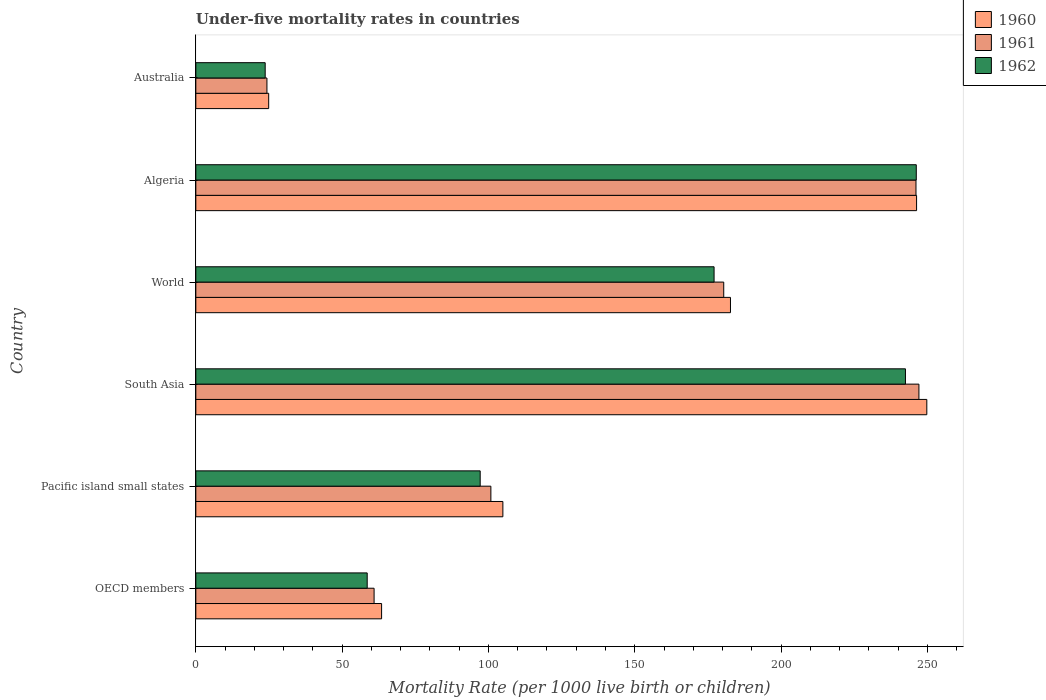Are the number of bars per tick equal to the number of legend labels?
Make the answer very short. Yes. Are the number of bars on each tick of the Y-axis equal?
Your answer should be very brief. Yes. How many bars are there on the 5th tick from the top?
Provide a succinct answer. 3. What is the under-five mortality rate in 1962 in Pacific island small states?
Provide a short and direct response. 97.17. Across all countries, what is the maximum under-five mortality rate in 1960?
Your answer should be very brief. 249.8. Across all countries, what is the minimum under-five mortality rate in 1960?
Your answer should be compact. 24.9. In which country was the under-five mortality rate in 1962 maximum?
Offer a very short reply. Algeria. In which country was the under-five mortality rate in 1962 minimum?
Provide a short and direct response. Australia. What is the total under-five mortality rate in 1961 in the graph?
Offer a terse response. 859.64. What is the difference between the under-five mortality rate in 1960 in Algeria and that in Australia?
Your response must be concise. 221.4. What is the difference between the under-five mortality rate in 1960 in Algeria and the under-five mortality rate in 1961 in Pacific island small states?
Offer a very short reply. 145.47. What is the average under-five mortality rate in 1960 per country?
Give a very brief answer. 145.35. What is the difference between the under-five mortality rate in 1961 and under-five mortality rate in 1960 in OECD members?
Keep it short and to the point. -2.57. What is the ratio of the under-five mortality rate in 1961 in OECD members to that in World?
Offer a very short reply. 0.34. Is the under-five mortality rate in 1960 in OECD members less than that in Pacific island small states?
Offer a very short reply. Yes. Is the difference between the under-five mortality rate in 1961 in Australia and Pacific island small states greater than the difference between the under-five mortality rate in 1960 in Australia and Pacific island small states?
Give a very brief answer. Yes. What is the difference between the highest and the second highest under-five mortality rate in 1962?
Offer a very short reply. 3.7. What is the difference between the highest and the lowest under-five mortality rate in 1960?
Offer a very short reply. 224.9. What does the 1st bar from the top in Algeria represents?
Your answer should be compact. 1962. What does the 2nd bar from the bottom in Australia represents?
Give a very brief answer. 1961. How many bars are there?
Offer a terse response. 18. How many countries are there in the graph?
Keep it short and to the point. 6. What is the difference between two consecutive major ticks on the X-axis?
Your answer should be compact. 50. Does the graph contain any zero values?
Offer a terse response. No. How are the legend labels stacked?
Provide a succinct answer. Vertical. What is the title of the graph?
Keep it short and to the point. Under-five mortality rates in countries. Does "2012" appear as one of the legend labels in the graph?
Offer a very short reply. No. What is the label or title of the X-axis?
Your answer should be compact. Mortality Rate (per 1000 live birth or children). What is the Mortality Rate (per 1000 live birth or children) in 1960 in OECD members?
Provide a short and direct response. 63.48. What is the Mortality Rate (per 1000 live birth or children) in 1961 in OECD members?
Your response must be concise. 60.92. What is the Mortality Rate (per 1000 live birth or children) of 1962 in OECD members?
Keep it short and to the point. 58.57. What is the Mortality Rate (per 1000 live birth or children) in 1960 in Pacific island small states?
Offer a terse response. 104.93. What is the Mortality Rate (per 1000 live birth or children) in 1961 in Pacific island small states?
Your answer should be very brief. 100.83. What is the Mortality Rate (per 1000 live birth or children) in 1962 in Pacific island small states?
Provide a succinct answer. 97.17. What is the Mortality Rate (per 1000 live birth or children) of 1960 in South Asia?
Give a very brief answer. 249.8. What is the Mortality Rate (per 1000 live birth or children) in 1961 in South Asia?
Offer a terse response. 247.1. What is the Mortality Rate (per 1000 live birth or children) of 1962 in South Asia?
Ensure brevity in your answer.  242.5. What is the Mortality Rate (per 1000 live birth or children) of 1960 in World?
Provide a succinct answer. 182.7. What is the Mortality Rate (per 1000 live birth or children) in 1961 in World?
Keep it short and to the point. 180.4. What is the Mortality Rate (per 1000 live birth or children) of 1962 in World?
Make the answer very short. 177.1. What is the Mortality Rate (per 1000 live birth or children) of 1960 in Algeria?
Provide a succinct answer. 246.3. What is the Mortality Rate (per 1000 live birth or children) in 1961 in Algeria?
Your response must be concise. 246.1. What is the Mortality Rate (per 1000 live birth or children) in 1962 in Algeria?
Your answer should be compact. 246.2. What is the Mortality Rate (per 1000 live birth or children) in 1960 in Australia?
Your answer should be very brief. 24.9. What is the Mortality Rate (per 1000 live birth or children) of 1961 in Australia?
Your answer should be very brief. 24.3. What is the Mortality Rate (per 1000 live birth or children) of 1962 in Australia?
Give a very brief answer. 23.7. Across all countries, what is the maximum Mortality Rate (per 1000 live birth or children) in 1960?
Provide a short and direct response. 249.8. Across all countries, what is the maximum Mortality Rate (per 1000 live birth or children) in 1961?
Make the answer very short. 247.1. Across all countries, what is the maximum Mortality Rate (per 1000 live birth or children) of 1962?
Your answer should be compact. 246.2. Across all countries, what is the minimum Mortality Rate (per 1000 live birth or children) in 1960?
Make the answer very short. 24.9. Across all countries, what is the minimum Mortality Rate (per 1000 live birth or children) in 1961?
Keep it short and to the point. 24.3. Across all countries, what is the minimum Mortality Rate (per 1000 live birth or children) of 1962?
Your response must be concise. 23.7. What is the total Mortality Rate (per 1000 live birth or children) in 1960 in the graph?
Your answer should be very brief. 872.11. What is the total Mortality Rate (per 1000 live birth or children) of 1961 in the graph?
Ensure brevity in your answer.  859.64. What is the total Mortality Rate (per 1000 live birth or children) of 1962 in the graph?
Offer a terse response. 845.24. What is the difference between the Mortality Rate (per 1000 live birth or children) of 1960 in OECD members and that in Pacific island small states?
Ensure brevity in your answer.  -41.45. What is the difference between the Mortality Rate (per 1000 live birth or children) in 1961 in OECD members and that in Pacific island small states?
Make the answer very short. -39.91. What is the difference between the Mortality Rate (per 1000 live birth or children) in 1962 in OECD members and that in Pacific island small states?
Keep it short and to the point. -38.61. What is the difference between the Mortality Rate (per 1000 live birth or children) of 1960 in OECD members and that in South Asia?
Offer a terse response. -186.32. What is the difference between the Mortality Rate (per 1000 live birth or children) of 1961 in OECD members and that in South Asia?
Provide a short and direct response. -186.18. What is the difference between the Mortality Rate (per 1000 live birth or children) of 1962 in OECD members and that in South Asia?
Offer a very short reply. -183.93. What is the difference between the Mortality Rate (per 1000 live birth or children) of 1960 in OECD members and that in World?
Give a very brief answer. -119.22. What is the difference between the Mortality Rate (per 1000 live birth or children) of 1961 in OECD members and that in World?
Make the answer very short. -119.48. What is the difference between the Mortality Rate (per 1000 live birth or children) in 1962 in OECD members and that in World?
Your answer should be very brief. -118.53. What is the difference between the Mortality Rate (per 1000 live birth or children) of 1960 in OECD members and that in Algeria?
Offer a terse response. -182.82. What is the difference between the Mortality Rate (per 1000 live birth or children) of 1961 in OECD members and that in Algeria?
Ensure brevity in your answer.  -185.18. What is the difference between the Mortality Rate (per 1000 live birth or children) in 1962 in OECD members and that in Algeria?
Give a very brief answer. -187.63. What is the difference between the Mortality Rate (per 1000 live birth or children) of 1960 in OECD members and that in Australia?
Your answer should be very brief. 38.58. What is the difference between the Mortality Rate (per 1000 live birth or children) of 1961 in OECD members and that in Australia?
Offer a terse response. 36.62. What is the difference between the Mortality Rate (per 1000 live birth or children) of 1962 in OECD members and that in Australia?
Offer a very short reply. 34.87. What is the difference between the Mortality Rate (per 1000 live birth or children) of 1960 in Pacific island small states and that in South Asia?
Your answer should be very brief. -144.87. What is the difference between the Mortality Rate (per 1000 live birth or children) in 1961 in Pacific island small states and that in South Asia?
Provide a succinct answer. -146.27. What is the difference between the Mortality Rate (per 1000 live birth or children) in 1962 in Pacific island small states and that in South Asia?
Keep it short and to the point. -145.33. What is the difference between the Mortality Rate (per 1000 live birth or children) of 1960 in Pacific island small states and that in World?
Your response must be concise. -77.77. What is the difference between the Mortality Rate (per 1000 live birth or children) of 1961 in Pacific island small states and that in World?
Your response must be concise. -79.57. What is the difference between the Mortality Rate (per 1000 live birth or children) in 1962 in Pacific island small states and that in World?
Your response must be concise. -79.93. What is the difference between the Mortality Rate (per 1000 live birth or children) in 1960 in Pacific island small states and that in Algeria?
Offer a very short reply. -141.37. What is the difference between the Mortality Rate (per 1000 live birth or children) in 1961 in Pacific island small states and that in Algeria?
Make the answer very short. -145.27. What is the difference between the Mortality Rate (per 1000 live birth or children) in 1962 in Pacific island small states and that in Algeria?
Keep it short and to the point. -149.03. What is the difference between the Mortality Rate (per 1000 live birth or children) in 1960 in Pacific island small states and that in Australia?
Ensure brevity in your answer.  80.03. What is the difference between the Mortality Rate (per 1000 live birth or children) in 1961 in Pacific island small states and that in Australia?
Offer a very short reply. 76.53. What is the difference between the Mortality Rate (per 1000 live birth or children) of 1962 in Pacific island small states and that in Australia?
Keep it short and to the point. 73.47. What is the difference between the Mortality Rate (per 1000 live birth or children) in 1960 in South Asia and that in World?
Your response must be concise. 67.1. What is the difference between the Mortality Rate (per 1000 live birth or children) in 1961 in South Asia and that in World?
Keep it short and to the point. 66.7. What is the difference between the Mortality Rate (per 1000 live birth or children) of 1962 in South Asia and that in World?
Offer a terse response. 65.4. What is the difference between the Mortality Rate (per 1000 live birth or children) in 1960 in South Asia and that in Algeria?
Provide a succinct answer. 3.5. What is the difference between the Mortality Rate (per 1000 live birth or children) of 1961 in South Asia and that in Algeria?
Your response must be concise. 1. What is the difference between the Mortality Rate (per 1000 live birth or children) of 1962 in South Asia and that in Algeria?
Provide a short and direct response. -3.7. What is the difference between the Mortality Rate (per 1000 live birth or children) of 1960 in South Asia and that in Australia?
Provide a short and direct response. 224.9. What is the difference between the Mortality Rate (per 1000 live birth or children) of 1961 in South Asia and that in Australia?
Your answer should be very brief. 222.8. What is the difference between the Mortality Rate (per 1000 live birth or children) in 1962 in South Asia and that in Australia?
Give a very brief answer. 218.8. What is the difference between the Mortality Rate (per 1000 live birth or children) of 1960 in World and that in Algeria?
Keep it short and to the point. -63.6. What is the difference between the Mortality Rate (per 1000 live birth or children) in 1961 in World and that in Algeria?
Provide a short and direct response. -65.7. What is the difference between the Mortality Rate (per 1000 live birth or children) in 1962 in World and that in Algeria?
Your answer should be compact. -69.1. What is the difference between the Mortality Rate (per 1000 live birth or children) of 1960 in World and that in Australia?
Your answer should be compact. 157.8. What is the difference between the Mortality Rate (per 1000 live birth or children) of 1961 in World and that in Australia?
Offer a terse response. 156.1. What is the difference between the Mortality Rate (per 1000 live birth or children) in 1962 in World and that in Australia?
Keep it short and to the point. 153.4. What is the difference between the Mortality Rate (per 1000 live birth or children) in 1960 in Algeria and that in Australia?
Give a very brief answer. 221.4. What is the difference between the Mortality Rate (per 1000 live birth or children) in 1961 in Algeria and that in Australia?
Make the answer very short. 221.8. What is the difference between the Mortality Rate (per 1000 live birth or children) of 1962 in Algeria and that in Australia?
Offer a terse response. 222.5. What is the difference between the Mortality Rate (per 1000 live birth or children) in 1960 in OECD members and the Mortality Rate (per 1000 live birth or children) in 1961 in Pacific island small states?
Give a very brief answer. -37.35. What is the difference between the Mortality Rate (per 1000 live birth or children) of 1960 in OECD members and the Mortality Rate (per 1000 live birth or children) of 1962 in Pacific island small states?
Make the answer very short. -33.69. What is the difference between the Mortality Rate (per 1000 live birth or children) in 1961 in OECD members and the Mortality Rate (per 1000 live birth or children) in 1962 in Pacific island small states?
Offer a very short reply. -36.26. What is the difference between the Mortality Rate (per 1000 live birth or children) of 1960 in OECD members and the Mortality Rate (per 1000 live birth or children) of 1961 in South Asia?
Your answer should be compact. -183.62. What is the difference between the Mortality Rate (per 1000 live birth or children) of 1960 in OECD members and the Mortality Rate (per 1000 live birth or children) of 1962 in South Asia?
Offer a terse response. -179.02. What is the difference between the Mortality Rate (per 1000 live birth or children) of 1961 in OECD members and the Mortality Rate (per 1000 live birth or children) of 1962 in South Asia?
Give a very brief answer. -181.58. What is the difference between the Mortality Rate (per 1000 live birth or children) of 1960 in OECD members and the Mortality Rate (per 1000 live birth or children) of 1961 in World?
Ensure brevity in your answer.  -116.92. What is the difference between the Mortality Rate (per 1000 live birth or children) in 1960 in OECD members and the Mortality Rate (per 1000 live birth or children) in 1962 in World?
Make the answer very short. -113.62. What is the difference between the Mortality Rate (per 1000 live birth or children) of 1961 in OECD members and the Mortality Rate (per 1000 live birth or children) of 1962 in World?
Make the answer very short. -116.18. What is the difference between the Mortality Rate (per 1000 live birth or children) of 1960 in OECD members and the Mortality Rate (per 1000 live birth or children) of 1961 in Algeria?
Offer a very short reply. -182.62. What is the difference between the Mortality Rate (per 1000 live birth or children) of 1960 in OECD members and the Mortality Rate (per 1000 live birth or children) of 1962 in Algeria?
Your answer should be compact. -182.72. What is the difference between the Mortality Rate (per 1000 live birth or children) of 1961 in OECD members and the Mortality Rate (per 1000 live birth or children) of 1962 in Algeria?
Ensure brevity in your answer.  -185.28. What is the difference between the Mortality Rate (per 1000 live birth or children) of 1960 in OECD members and the Mortality Rate (per 1000 live birth or children) of 1961 in Australia?
Provide a short and direct response. 39.18. What is the difference between the Mortality Rate (per 1000 live birth or children) in 1960 in OECD members and the Mortality Rate (per 1000 live birth or children) in 1962 in Australia?
Offer a terse response. 39.78. What is the difference between the Mortality Rate (per 1000 live birth or children) of 1961 in OECD members and the Mortality Rate (per 1000 live birth or children) of 1962 in Australia?
Offer a terse response. 37.22. What is the difference between the Mortality Rate (per 1000 live birth or children) of 1960 in Pacific island small states and the Mortality Rate (per 1000 live birth or children) of 1961 in South Asia?
Offer a very short reply. -142.17. What is the difference between the Mortality Rate (per 1000 live birth or children) of 1960 in Pacific island small states and the Mortality Rate (per 1000 live birth or children) of 1962 in South Asia?
Your response must be concise. -137.57. What is the difference between the Mortality Rate (per 1000 live birth or children) in 1961 in Pacific island small states and the Mortality Rate (per 1000 live birth or children) in 1962 in South Asia?
Provide a short and direct response. -141.67. What is the difference between the Mortality Rate (per 1000 live birth or children) in 1960 in Pacific island small states and the Mortality Rate (per 1000 live birth or children) in 1961 in World?
Keep it short and to the point. -75.47. What is the difference between the Mortality Rate (per 1000 live birth or children) in 1960 in Pacific island small states and the Mortality Rate (per 1000 live birth or children) in 1962 in World?
Offer a very short reply. -72.17. What is the difference between the Mortality Rate (per 1000 live birth or children) in 1961 in Pacific island small states and the Mortality Rate (per 1000 live birth or children) in 1962 in World?
Your answer should be very brief. -76.27. What is the difference between the Mortality Rate (per 1000 live birth or children) in 1960 in Pacific island small states and the Mortality Rate (per 1000 live birth or children) in 1961 in Algeria?
Provide a short and direct response. -141.17. What is the difference between the Mortality Rate (per 1000 live birth or children) of 1960 in Pacific island small states and the Mortality Rate (per 1000 live birth or children) of 1962 in Algeria?
Offer a very short reply. -141.27. What is the difference between the Mortality Rate (per 1000 live birth or children) in 1961 in Pacific island small states and the Mortality Rate (per 1000 live birth or children) in 1962 in Algeria?
Make the answer very short. -145.37. What is the difference between the Mortality Rate (per 1000 live birth or children) of 1960 in Pacific island small states and the Mortality Rate (per 1000 live birth or children) of 1961 in Australia?
Offer a terse response. 80.63. What is the difference between the Mortality Rate (per 1000 live birth or children) of 1960 in Pacific island small states and the Mortality Rate (per 1000 live birth or children) of 1962 in Australia?
Give a very brief answer. 81.23. What is the difference between the Mortality Rate (per 1000 live birth or children) in 1961 in Pacific island small states and the Mortality Rate (per 1000 live birth or children) in 1962 in Australia?
Ensure brevity in your answer.  77.13. What is the difference between the Mortality Rate (per 1000 live birth or children) of 1960 in South Asia and the Mortality Rate (per 1000 live birth or children) of 1961 in World?
Your answer should be compact. 69.4. What is the difference between the Mortality Rate (per 1000 live birth or children) in 1960 in South Asia and the Mortality Rate (per 1000 live birth or children) in 1962 in World?
Make the answer very short. 72.7. What is the difference between the Mortality Rate (per 1000 live birth or children) in 1960 in South Asia and the Mortality Rate (per 1000 live birth or children) in 1961 in Algeria?
Offer a terse response. 3.7. What is the difference between the Mortality Rate (per 1000 live birth or children) in 1961 in South Asia and the Mortality Rate (per 1000 live birth or children) in 1962 in Algeria?
Your response must be concise. 0.9. What is the difference between the Mortality Rate (per 1000 live birth or children) of 1960 in South Asia and the Mortality Rate (per 1000 live birth or children) of 1961 in Australia?
Your answer should be compact. 225.5. What is the difference between the Mortality Rate (per 1000 live birth or children) in 1960 in South Asia and the Mortality Rate (per 1000 live birth or children) in 1962 in Australia?
Offer a terse response. 226.1. What is the difference between the Mortality Rate (per 1000 live birth or children) of 1961 in South Asia and the Mortality Rate (per 1000 live birth or children) of 1962 in Australia?
Keep it short and to the point. 223.4. What is the difference between the Mortality Rate (per 1000 live birth or children) of 1960 in World and the Mortality Rate (per 1000 live birth or children) of 1961 in Algeria?
Keep it short and to the point. -63.4. What is the difference between the Mortality Rate (per 1000 live birth or children) in 1960 in World and the Mortality Rate (per 1000 live birth or children) in 1962 in Algeria?
Your answer should be very brief. -63.5. What is the difference between the Mortality Rate (per 1000 live birth or children) of 1961 in World and the Mortality Rate (per 1000 live birth or children) of 1962 in Algeria?
Provide a short and direct response. -65.8. What is the difference between the Mortality Rate (per 1000 live birth or children) of 1960 in World and the Mortality Rate (per 1000 live birth or children) of 1961 in Australia?
Offer a terse response. 158.4. What is the difference between the Mortality Rate (per 1000 live birth or children) in 1960 in World and the Mortality Rate (per 1000 live birth or children) in 1962 in Australia?
Keep it short and to the point. 159. What is the difference between the Mortality Rate (per 1000 live birth or children) in 1961 in World and the Mortality Rate (per 1000 live birth or children) in 1962 in Australia?
Provide a succinct answer. 156.7. What is the difference between the Mortality Rate (per 1000 live birth or children) of 1960 in Algeria and the Mortality Rate (per 1000 live birth or children) of 1961 in Australia?
Offer a terse response. 222. What is the difference between the Mortality Rate (per 1000 live birth or children) of 1960 in Algeria and the Mortality Rate (per 1000 live birth or children) of 1962 in Australia?
Offer a terse response. 222.6. What is the difference between the Mortality Rate (per 1000 live birth or children) of 1961 in Algeria and the Mortality Rate (per 1000 live birth or children) of 1962 in Australia?
Offer a very short reply. 222.4. What is the average Mortality Rate (per 1000 live birth or children) in 1960 per country?
Make the answer very short. 145.35. What is the average Mortality Rate (per 1000 live birth or children) in 1961 per country?
Offer a very short reply. 143.27. What is the average Mortality Rate (per 1000 live birth or children) in 1962 per country?
Give a very brief answer. 140.87. What is the difference between the Mortality Rate (per 1000 live birth or children) in 1960 and Mortality Rate (per 1000 live birth or children) in 1961 in OECD members?
Make the answer very short. 2.57. What is the difference between the Mortality Rate (per 1000 live birth or children) of 1960 and Mortality Rate (per 1000 live birth or children) of 1962 in OECD members?
Offer a terse response. 4.92. What is the difference between the Mortality Rate (per 1000 live birth or children) in 1961 and Mortality Rate (per 1000 live birth or children) in 1962 in OECD members?
Keep it short and to the point. 2.35. What is the difference between the Mortality Rate (per 1000 live birth or children) in 1960 and Mortality Rate (per 1000 live birth or children) in 1961 in Pacific island small states?
Provide a succinct answer. 4.1. What is the difference between the Mortality Rate (per 1000 live birth or children) in 1960 and Mortality Rate (per 1000 live birth or children) in 1962 in Pacific island small states?
Provide a short and direct response. 7.76. What is the difference between the Mortality Rate (per 1000 live birth or children) in 1961 and Mortality Rate (per 1000 live birth or children) in 1962 in Pacific island small states?
Provide a succinct answer. 3.66. What is the difference between the Mortality Rate (per 1000 live birth or children) of 1960 and Mortality Rate (per 1000 live birth or children) of 1962 in World?
Provide a succinct answer. 5.6. What is the difference between the Mortality Rate (per 1000 live birth or children) in 1960 and Mortality Rate (per 1000 live birth or children) in 1961 in Algeria?
Provide a short and direct response. 0.2. What is the difference between the Mortality Rate (per 1000 live birth or children) of 1960 and Mortality Rate (per 1000 live birth or children) of 1962 in Algeria?
Offer a very short reply. 0.1. What is the difference between the Mortality Rate (per 1000 live birth or children) of 1961 and Mortality Rate (per 1000 live birth or children) of 1962 in Algeria?
Keep it short and to the point. -0.1. What is the difference between the Mortality Rate (per 1000 live birth or children) of 1960 and Mortality Rate (per 1000 live birth or children) of 1962 in Australia?
Your answer should be compact. 1.2. What is the ratio of the Mortality Rate (per 1000 live birth or children) in 1960 in OECD members to that in Pacific island small states?
Your answer should be very brief. 0.6. What is the ratio of the Mortality Rate (per 1000 live birth or children) of 1961 in OECD members to that in Pacific island small states?
Offer a terse response. 0.6. What is the ratio of the Mortality Rate (per 1000 live birth or children) in 1962 in OECD members to that in Pacific island small states?
Provide a succinct answer. 0.6. What is the ratio of the Mortality Rate (per 1000 live birth or children) of 1960 in OECD members to that in South Asia?
Provide a succinct answer. 0.25. What is the ratio of the Mortality Rate (per 1000 live birth or children) in 1961 in OECD members to that in South Asia?
Provide a succinct answer. 0.25. What is the ratio of the Mortality Rate (per 1000 live birth or children) of 1962 in OECD members to that in South Asia?
Offer a terse response. 0.24. What is the ratio of the Mortality Rate (per 1000 live birth or children) of 1960 in OECD members to that in World?
Offer a very short reply. 0.35. What is the ratio of the Mortality Rate (per 1000 live birth or children) of 1961 in OECD members to that in World?
Offer a very short reply. 0.34. What is the ratio of the Mortality Rate (per 1000 live birth or children) in 1962 in OECD members to that in World?
Offer a very short reply. 0.33. What is the ratio of the Mortality Rate (per 1000 live birth or children) in 1960 in OECD members to that in Algeria?
Offer a terse response. 0.26. What is the ratio of the Mortality Rate (per 1000 live birth or children) in 1961 in OECD members to that in Algeria?
Your answer should be compact. 0.25. What is the ratio of the Mortality Rate (per 1000 live birth or children) in 1962 in OECD members to that in Algeria?
Ensure brevity in your answer.  0.24. What is the ratio of the Mortality Rate (per 1000 live birth or children) of 1960 in OECD members to that in Australia?
Provide a short and direct response. 2.55. What is the ratio of the Mortality Rate (per 1000 live birth or children) of 1961 in OECD members to that in Australia?
Your answer should be compact. 2.51. What is the ratio of the Mortality Rate (per 1000 live birth or children) of 1962 in OECD members to that in Australia?
Ensure brevity in your answer.  2.47. What is the ratio of the Mortality Rate (per 1000 live birth or children) of 1960 in Pacific island small states to that in South Asia?
Give a very brief answer. 0.42. What is the ratio of the Mortality Rate (per 1000 live birth or children) of 1961 in Pacific island small states to that in South Asia?
Give a very brief answer. 0.41. What is the ratio of the Mortality Rate (per 1000 live birth or children) of 1962 in Pacific island small states to that in South Asia?
Your response must be concise. 0.4. What is the ratio of the Mortality Rate (per 1000 live birth or children) in 1960 in Pacific island small states to that in World?
Your response must be concise. 0.57. What is the ratio of the Mortality Rate (per 1000 live birth or children) in 1961 in Pacific island small states to that in World?
Ensure brevity in your answer.  0.56. What is the ratio of the Mortality Rate (per 1000 live birth or children) of 1962 in Pacific island small states to that in World?
Your answer should be very brief. 0.55. What is the ratio of the Mortality Rate (per 1000 live birth or children) of 1960 in Pacific island small states to that in Algeria?
Offer a very short reply. 0.43. What is the ratio of the Mortality Rate (per 1000 live birth or children) of 1961 in Pacific island small states to that in Algeria?
Your answer should be very brief. 0.41. What is the ratio of the Mortality Rate (per 1000 live birth or children) of 1962 in Pacific island small states to that in Algeria?
Keep it short and to the point. 0.39. What is the ratio of the Mortality Rate (per 1000 live birth or children) of 1960 in Pacific island small states to that in Australia?
Your answer should be compact. 4.21. What is the ratio of the Mortality Rate (per 1000 live birth or children) in 1961 in Pacific island small states to that in Australia?
Your answer should be very brief. 4.15. What is the ratio of the Mortality Rate (per 1000 live birth or children) of 1962 in Pacific island small states to that in Australia?
Give a very brief answer. 4.1. What is the ratio of the Mortality Rate (per 1000 live birth or children) in 1960 in South Asia to that in World?
Make the answer very short. 1.37. What is the ratio of the Mortality Rate (per 1000 live birth or children) in 1961 in South Asia to that in World?
Ensure brevity in your answer.  1.37. What is the ratio of the Mortality Rate (per 1000 live birth or children) in 1962 in South Asia to that in World?
Your answer should be very brief. 1.37. What is the ratio of the Mortality Rate (per 1000 live birth or children) of 1960 in South Asia to that in Algeria?
Keep it short and to the point. 1.01. What is the ratio of the Mortality Rate (per 1000 live birth or children) of 1961 in South Asia to that in Algeria?
Keep it short and to the point. 1. What is the ratio of the Mortality Rate (per 1000 live birth or children) in 1962 in South Asia to that in Algeria?
Keep it short and to the point. 0.98. What is the ratio of the Mortality Rate (per 1000 live birth or children) in 1960 in South Asia to that in Australia?
Provide a short and direct response. 10.03. What is the ratio of the Mortality Rate (per 1000 live birth or children) in 1961 in South Asia to that in Australia?
Provide a short and direct response. 10.17. What is the ratio of the Mortality Rate (per 1000 live birth or children) in 1962 in South Asia to that in Australia?
Provide a short and direct response. 10.23. What is the ratio of the Mortality Rate (per 1000 live birth or children) in 1960 in World to that in Algeria?
Offer a very short reply. 0.74. What is the ratio of the Mortality Rate (per 1000 live birth or children) in 1961 in World to that in Algeria?
Offer a very short reply. 0.73. What is the ratio of the Mortality Rate (per 1000 live birth or children) of 1962 in World to that in Algeria?
Ensure brevity in your answer.  0.72. What is the ratio of the Mortality Rate (per 1000 live birth or children) in 1960 in World to that in Australia?
Offer a very short reply. 7.34. What is the ratio of the Mortality Rate (per 1000 live birth or children) of 1961 in World to that in Australia?
Offer a terse response. 7.42. What is the ratio of the Mortality Rate (per 1000 live birth or children) in 1962 in World to that in Australia?
Make the answer very short. 7.47. What is the ratio of the Mortality Rate (per 1000 live birth or children) of 1960 in Algeria to that in Australia?
Ensure brevity in your answer.  9.89. What is the ratio of the Mortality Rate (per 1000 live birth or children) of 1961 in Algeria to that in Australia?
Your answer should be compact. 10.13. What is the ratio of the Mortality Rate (per 1000 live birth or children) of 1962 in Algeria to that in Australia?
Provide a short and direct response. 10.39. What is the difference between the highest and the second highest Mortality Rate (per 1000 live birth or children) in 1962?
Offer a very short reply. 3.7. What is the difference between the highest and the lowest Mortality Rate (per 1000 live birth or children) in 1960?
Provide a succinct answer. 224.9. What is the difference between the highest and the lowest Mortality Rate (per 1000 live birth or children) of 1961?
Your answer should be very brief. 222.8. What is the difference between the highest and the lowest Mortality Rate (per 1000 live birth or children) in 1962?
Your response must be concise. 222.5. 